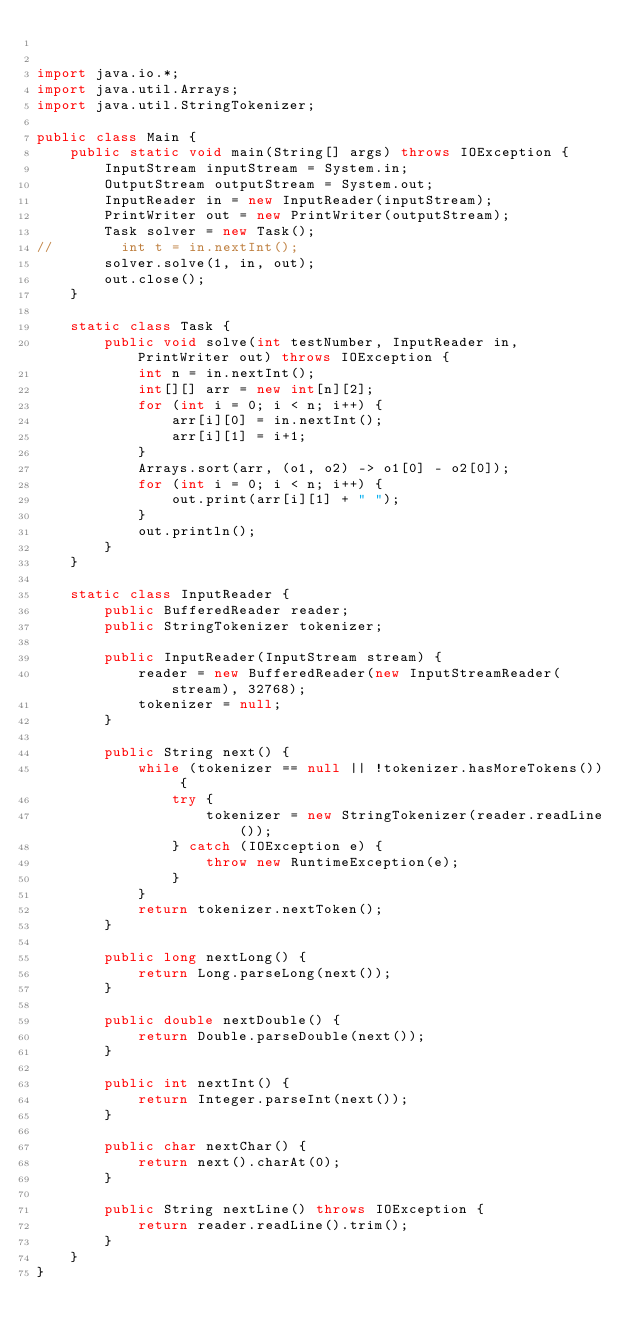Convert code to text. <code><loc_0><loc_0><loc_500><loc_500><_Java_>

import java.io.*;
import java.util.Arrays;
import java.util.StringTokenizer;

public class Main {
    public static void main(String[] args) throws IOException {
        InputStream inputStream = System.in;
        OutputStream outputStream = System.out;
        InputReader in = new InputReader(inputStream);
        PrintWriter out = new PrintWriter(outputStream);
        Task solver = new Task();
//        int t = in.nextInt();
        solver.solve(1, in, out);
        out.close();
    }

    static class Task {
        public void solve(int testNumber, InputReader in, PrintWriter out) throws IOException {
            int n = in.nextInt();
            int[][] arr = new int[n][2];
            for (int i = 0; i < n; i++) {
                arr[i][0] = in.nextInt();
                arr[i][1] = i+1;
            }
            Arrays.sort(arr, (o1, o2) -> o1[0] - o2[0]);
            for (int i = 0; i < n; i++) {
                out.print(arr[i][1] + " ");
            }
            out.println();
        }
    }

    static class InputReader {
        public BufferedReader reader;
        public StringTokenizer tokenizer;

        public InputReader(InputStream stream) {
            reader = new BufferedReader(new InputStreamReader(stream), 32768);
            tokenizer = null;
        }

        public String next() {
            while (tokenizer == null || !tokenizer.hasMoreTokens()) {
                try {
                    tokenizer = new StringTokenizer(reader.readLine());
                } catch (IOException e) {
                    throw new RuntimeException(e);
                }
            }
            return tokenizer.nextToken();
        }

        public long nextLong() {
            return Long.parseLong(next());
        }

        public double nextDouble() {
            return Double.parseDouble(next());
        }

        public int nextInt() {
            return Integer.parseInt(next());
        }

        public char nextChar() {
            return next().charAt(0);
        }

        public String nextLine() throws IOException {
            return reader.readLine().trim();
        }
    }
}
</code> 